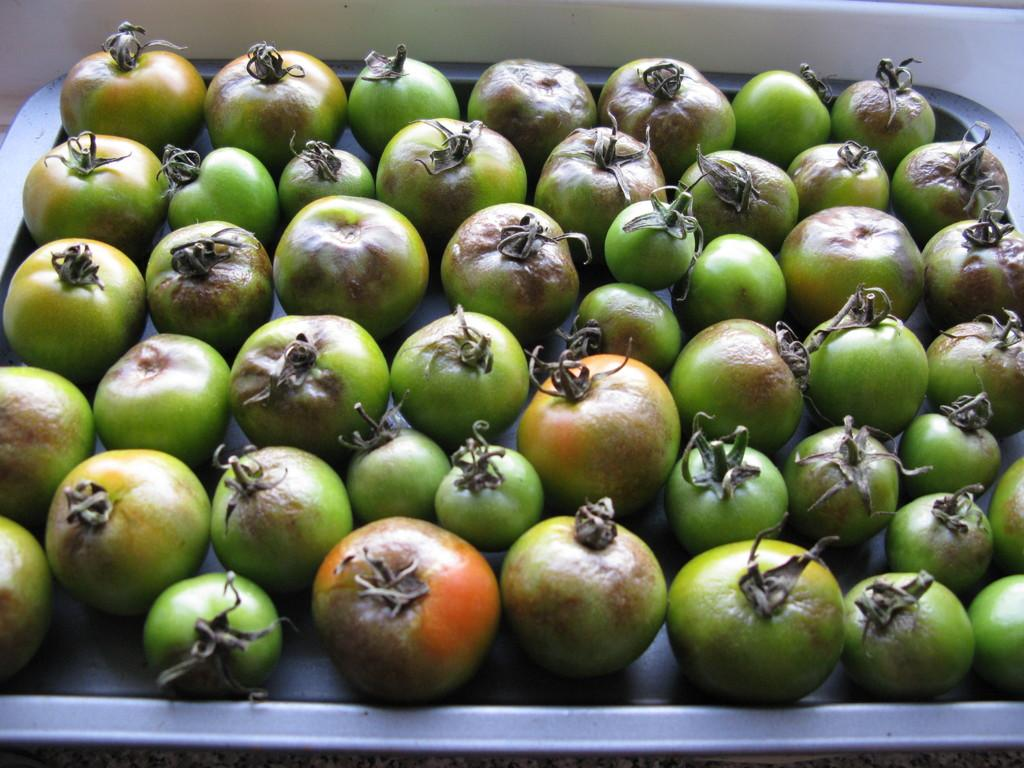Where was the image taken? The image was taken indoors. What can be seen on the tray in the image? There are green tomatoes on a tray in the image. How many dogs are playing with the glove in the image? There are no dogs or gloves present in the image. What type of grass can be seen growing in the image? There is no grass visible in the image, as it was taken indoors. 